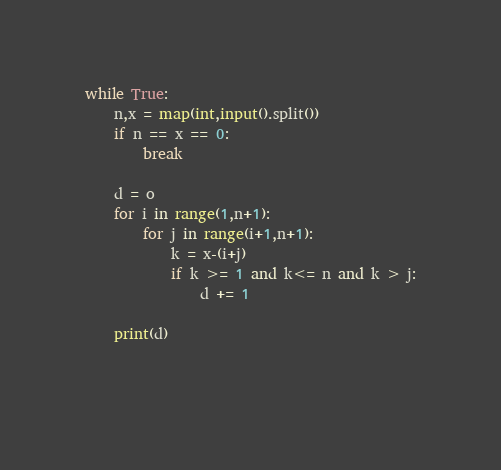<code> <loc_0><loc_0><loc_500><loc_500><_Python_>while True:
    n,x = map(int,input().split())
    if n == x == 0:
        break
    
    d = o
    for i in range(1,n+1):
        for j in range(i+1,n+1):
            k = x-(i+j)
            if k >= 1 and k<= n and k > j:
                d += 1
    
    print(d)
        
    
</code> 